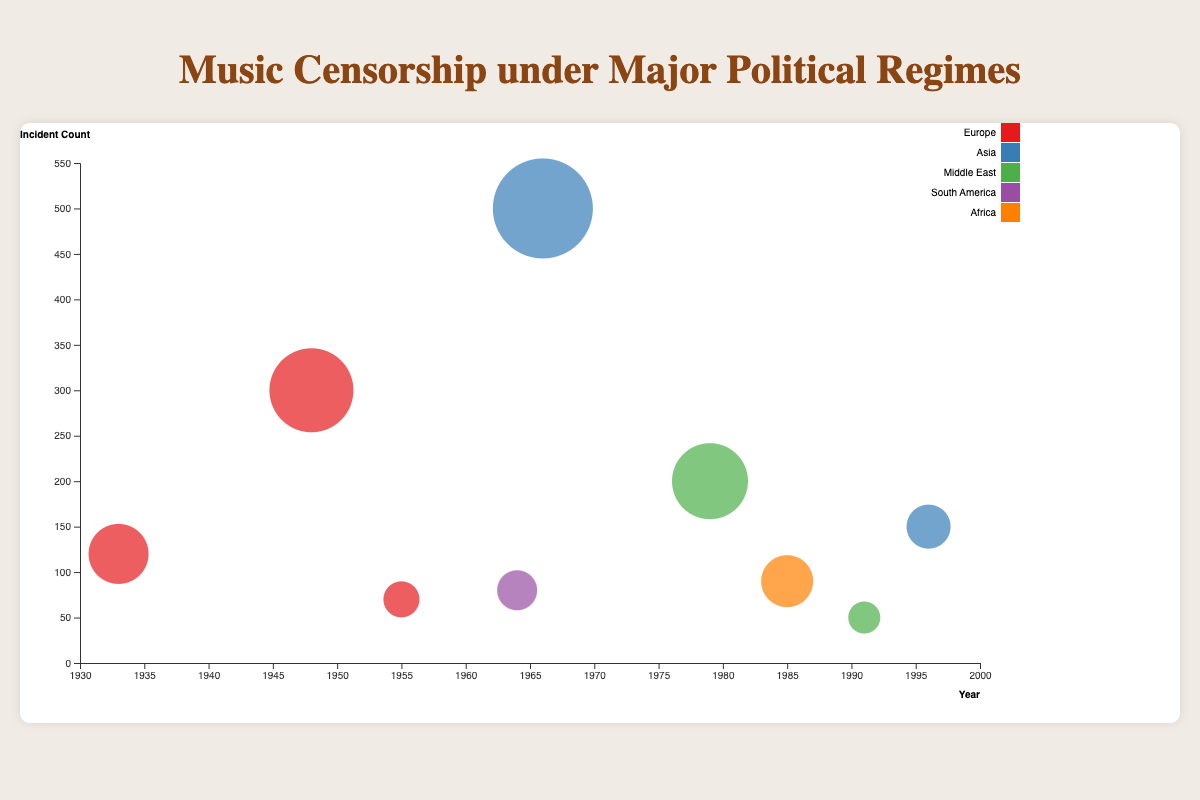How many incidents were recorded under People's Republic of China? Locate the bubble labeled "People's Republic of China" on the chart. The Y-axis value indicates the incident count, which is 500.
Answer: 500 What is the title of the chart? Read the title text positioned at the top of the chart, which is clearly stated.
Answer: Music Censorship under Major Political Regimes Which region has the largest bubble and what regime does it represent? The largest bubble signifies the highest number of acclaimed artists impacted. Locate it and note its corresponding regime and region. The largest bubble belongs to People's Republic of China, in the Asia region.
Answer: Asia, People's Republic of China Which regime in Europe had the earliest music censorship incidents according to the chart? Look at the X-axis (years) for the earliest data point under the "Europe" region. This bubble represents Nazi Germany in 1933.
Answer: Nazi Germany How many acclaimed artists were impacted by music censorship in Francoist Spain? Find the bubble labeled "Francoist Spain." The bubble size represents the number of acclaimed artists impacted, which is 20.
Answer: 20 What's the difference in incident count between Soviet Union and Apartheid South Africa? Identify the incident counts for Soviet Union (300) and Apartheid South Africa (90). Calculate the difference (300 - 90).
Answer: 210 Which regime in the Middle East had fewer music censorship incidents, Islamic Republic of Iran or Ba'athist Iraq? Compare the Y-axis values for Islamic Republic of Iran (200) and Ba'athist Iraq (50). Ba'athist Iraq had fewer incidents.
Answer: Ba'athist Iraq What's the average number of acclaimed artists impacted by music censorship in both the Military Dictatorship of Brazil and Taliban Rule? Sum the number of acclaimed artists impacted: Military Dictatorship of Brazil (25) + Taliban Rule (30) = 55. Divide by 2 for the average (55 / 2).
Answer: 27.5 How many regions are represented in the chart? Count the number of distinct colors (regions) used for the bubbles. There are five regions: Europe, Asia, Middle East, South America, and Africa.
Answer: 5 Which regime caused both high incident count and high number of acclaimed artists impacted, and what does this suggest? Both high metrics can be identified by examining bubbles that are both high on the Y-axis and large in size. The People's Republic of China had the highest incident count (500) and highest number of acclaimed artists impacted (100). This suggests intensive and broad censorship.
Answer: People's Republic of China 